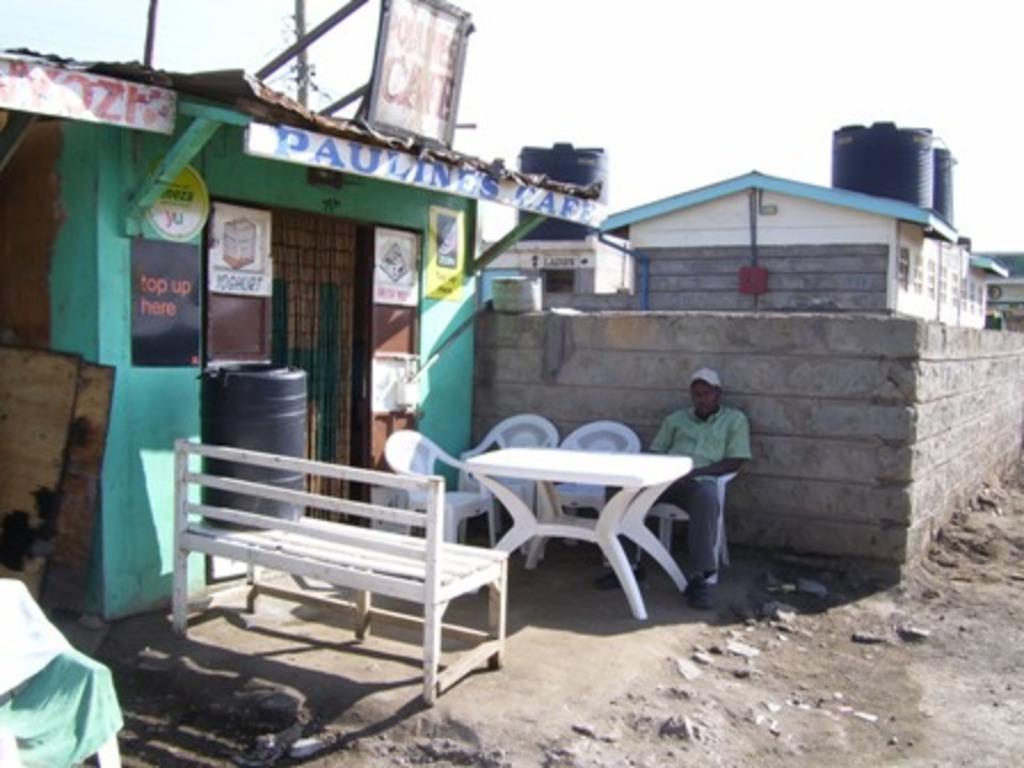Could you give a brief overview of what you see in this image? In this picture I can see few houses and few boards with some text and a can on the bench. I can see chairs and a human sitting on the chair and I can see a table and few water tanks on the house and a cloudy sky. 